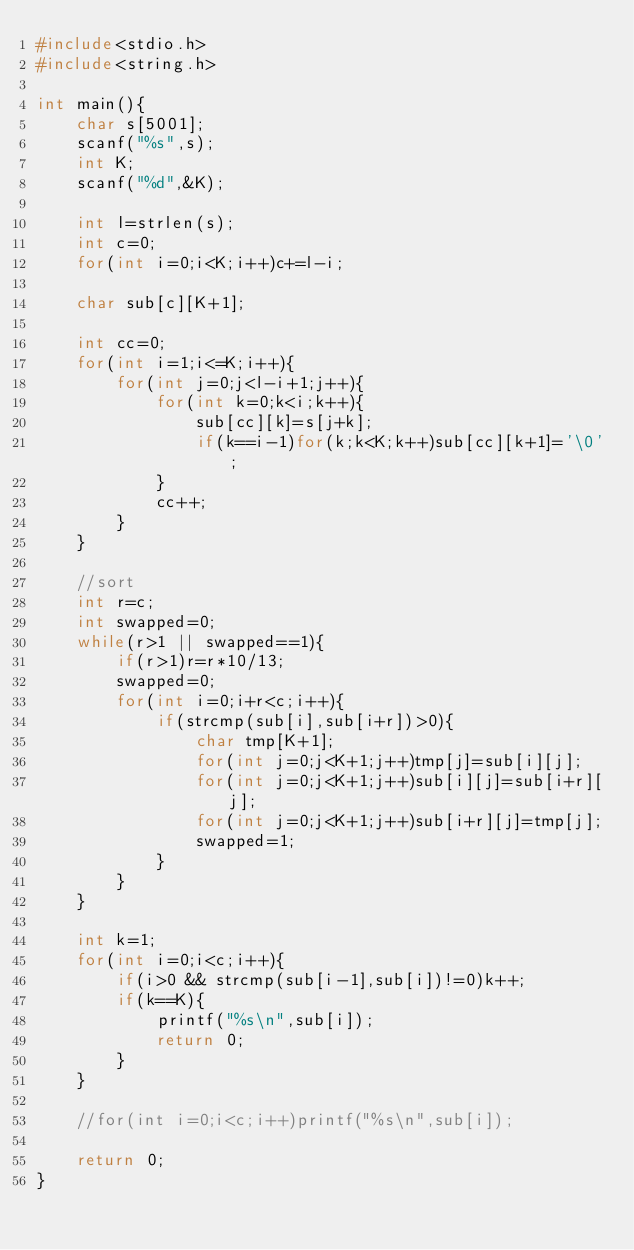<code> <loc_0><loc_0><loc_500><loc_500><_C_>#include<stdio.h>
#include<string.h>

int main(){
	char s[5001];
	scanf("%s",s);
	int K;
	scanf("%d",&K);
	
	int l=strlen(s);
	int c=0;
	for(int i=0;i<K;i++)c+=l-i;
	
	char sub[c][K+1];
	
	int cc=0;
	for(int i=1;i<=K;i++){
		for(int j=0;j<l-i+1;j++){
			for(int k=0;k<i;k++){
				sub[cc][k]=s[j+k];
				if(k==i-1)for(k;k<K;k++)sub[cc][k+1]='\0';
			}
			cc++;
		}
	}
	
	//sort
	int r=c;
	int swapped=0;
	while(r>1 || swapped==1){
		if(r>1)r=r*10/13;
		swapped=0;
		for(int i=0;i+r<c;i++){
			if(strcmp(sub[i],sub[i+r])>0){
				char tmp[K+1];
				for(int j=0;j<K+1;j++)tmp[j]=sub[i][j];
				for(int j=0;j<K+1;j++)sub[i][j]=sub[i+r][j];
				for(int j=0;j<K+1;j++)sub[i+r][j]=tmp[j];
				swapped=1;
			}
		}
	}
	
	int k=1;
	for(int i=0;i<c;i++){
		if(i>0 && strcmp(sub[i-1],sub[i])!=0)k++;
		if(k==K){
			printf("%s\n",sub[i]);
			return 0;
		}
	}
	
	//for(int i=0;i<c;i++)printf("%s\n",sub[i]);
	
	return 0;
}</code> 